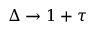Convert formula to latex. <formula><loc_0><loc_0><loc_500><loc_500>\Delta \rightarrow 1 + \tau</formula> 